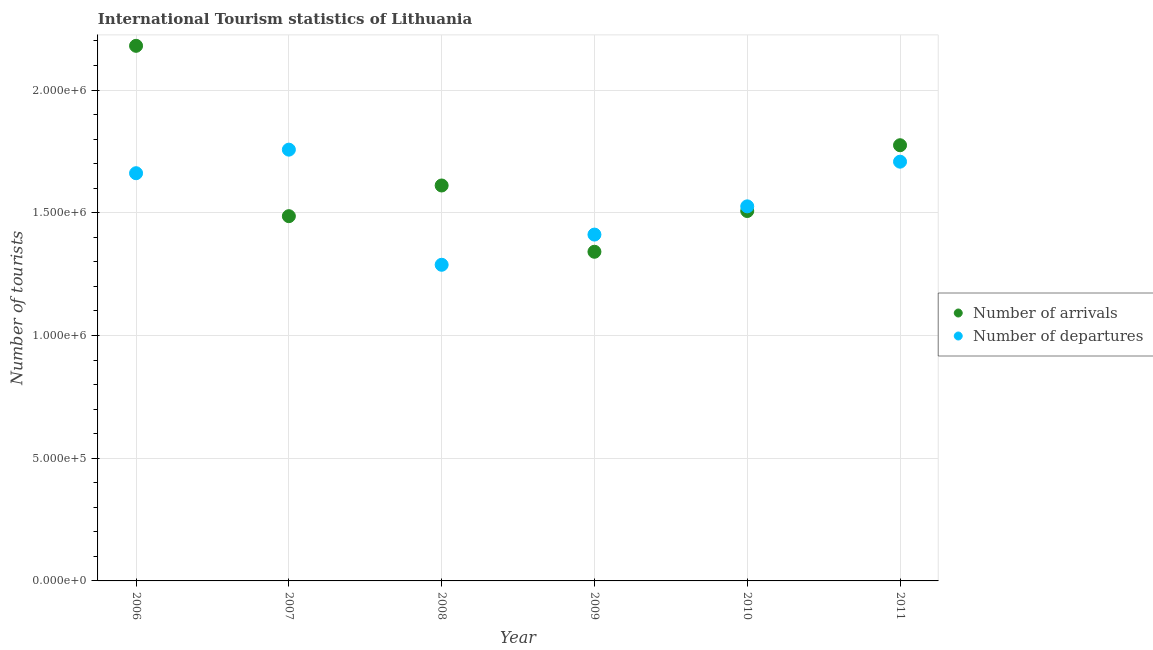How many different coloured dotlines are there?
Give a very brief answer. 2. What is the number of tourist departures in 2011?
Provide a succinct answer. 1.71e+06. Across all years, what is the maximum number of tourist departures?
Your answer should be very brief. 1.76e+06. Across all years, what is the minimum number of tourist departures?
Offer a very short reply. 1.29e+06. In which year was the number of tourist arrivals maximum?
Your response must be concise. 2006. What is the total number of tourist arrivals in the graph?
Provide a succinct answer. 9.90e+06. What is the difference between the number of tourist arrivals in 2008 and that in 2010?
Make the answer very short. 1.04e+05. What is the difference between the number of tourist departures in 2011 and the number of tourist arrivals in 2009?
Make the answer very short. 3.67e+05. What is the average number of tourist departures per year?
Provide a short and direct response. 1.56e+06. In the year 2009, what is the difference between the number of tourist arrivals and number of tourist departures?
Give a very brief answer. -7.00e+04. In how many years, is the number of tourist arrivals greater than 500000?
Make the answer very short. 6. What is the ratio of the number of tourist departures in 2010 to that in 2011?
Keep it short and to the point. 0.89. Is the number of tourist departures in 2008 less than that in 2009?
Give a very brief answer. Yes. Is the difference between the number of tourist departures in 2006 and 2008 greater than the difference between the number of tourist arrivals in 2006 and 2008?
Provide a succinct answer. No. What is the difference between the highest and the second highest number of tourist arrivals?
Offer a very short reply. 4.05e+05. What is the difference between the highest and the lowest number of tourist departures?
Give a very brief answer. 4.69e+05. In how many years, is the number of tourist arrivals greater than the average number of tourist arrivals taken over all years?
Provide a succinct answer. 2. Does the number of tourist arrivals monotonically increase over the years?
Your answer should be very brief. No. Is the number of tourist arrivals strictly less than the number of tourist departures over the years?
Offer a very short reply. No. What is the difference between two consecutive major ticks on the Y-axis?
Make the answer very short. 5.00e+05. Does the graph contain grids?
Your response must be concise. Yes. Where does the legend appear in the graph?
Your answer should be very brief. Center right. How many legend labels are there?
Make the answer very short. 2. What is the title of the graph?
Provide a succinct answer. International Tourism statistics of Lithuania. Does "Death rate" appear as one of the legend labels in the graph?
Give a very brief answer. No. What is the label or title of the Y-axis?
Offer a very short reply. Number of tourists. What is the Number of tourists of Number of arrivals in 2006?
Your answer should be very brief. 2.18e+06. What is the Number of tourists of Number of departures in 2006?
Keep it short and to the point. 1.66e+06. What is the Number of tourists in Number of arrivals in 2007?
Your answer should be compact. 1.49e+06. What is the Number of tourists of Number of departures in 2007?
Give a very brief answer. 1.76e+06. What is the Number of tourists of Number of arrivals in 2008?
Your response must be concise. 1.61e+06. What is the Number of tourists of Number of departures in 2008?
Give a very brief answer. 1.29e+06. What is the Number of tourists of Number of arrivals in 2009?
Give a very brief answer. 1.34e+06. What is the Number of tourists of Number of departures in 2009?
Give a very brief answer. 1.41e+06. What is the Number of tourists of Number of arrivals in 2010?
Provide a succinct answer. 1.51e+06. What is the Number of tourists of Number of departures in 2010?
Make the answer very short. 1.53e+06. What is the Number of tourists in Number of arrivals in 2011?
Your answer should be compact. 1.78e+06. What is the Number of tourists of Number of departures in 2011?
Provide a succinct answer. 1.71e+06. Across all years, what is the maximum Number of tourists of Number of arrivals?
Provide a short and direct response. 2.18e+06. Across all years, what is the maximum Number of tourists of Number of departures?
Offer a terse response. 1.76e+06. Across all years, what is the minimum Number of tourists of Number of arrivals?
Offer a very short reply. 1.34e+06. Across all years, what is the minimum Number of tourists of Number of departures?
Offer a very short reply. 1.29e+06. What is the total Number of tourists in Number of arrivals in the graph?
Make the answer very short. 9.90e+06. What is the total Number of tourists in Number of departures in the graph?
Give a very brief answer. 9.35e+06. What is the difference between the Number of tourists in Number of arrivals in 2006 and that in 2007?
Your response must be concise. 6.94e+05. What is the difference between the Number of tourists in Number of departures in 2006 and that in 2007?
Ensure brevity in your answer.  -9.60e+04. What is the difference between the Number of tourists of Number of arrivals in 2006 and that in 2008?
Make the answer very short. 5.69e+05. What is the difference between the Number of tourists of Number of departures in 2006 and that in 2008?
Your answer should be very brief. 3.73e+05. What is the difference between the Number of tourists of Number of arrivals in 2006 and that in 2009?
Ensure brevity in your answer.  8.39e+05. What is the difference between the Number of tourists of Number of departures in 2006 and that in 2009?
Your response must be concise. 2.50e+05. What is the difference between the Number of tourists in Number of arrivals in 2006 and that in 2010?
Keep it short and to the point. 6.73e+05. What is the difference between the Number of tourists in Number of departures in 2006 and that in 2010?
Offer a very short reply. 1.35e+05. What is the difference between the Number of tourists of Number of arrivals in 2006 and that in 2011?
Offer a terse response. 4.05e+05. What is the difference between the Number of tourists of Number of departures in 2006 and that in 2011?
Offer a very short reply. -4.70e+04. What is the difference between the Number of tourists of Number of arrivals in 2007 and that in 2008?
Your response must be concise. -1.25e+05. What is the difference between the Number of tourists in Number of departures in 2007 and that in 2008?
Provide a succinct answer. 4.69e+05. What is the difference between the Number of tourists in Number of arrivals in 2007 and that in 2009?
Your response must be concise. 1.45e+05. What is the difference between the Number of tourists in Number of departures in 2007 and that in 2009?
Make the answer very short. 3.46e+05. What is the difference between the Number of tourists of Number of arrivals in 2007 and that in 2010?
Provide a short and direct response. -2.10e+04. What is the difference between the Number of tourists of Number of departures in 2007 and that in 2010?
Ensure brevity in your answer.  2.31e+05. What is the difference between the Number of tourists in Number of arrivals in 2007 and that in 2011?
Your answer should be very brief. -2.89e+05. What is the difference between the Number of tourists in Number of departures in 2007 and that in 2011?
Your response must be concise. 4.90e+04. What is the difference between the Number of tourists of Number of departures in 2008 and that in 2009?
Make the answer very short. -1.23e+05. What is the difference between the Number of tourists in Number of arrivals in 2008 and that in 2010?
Keep it short and to the point. 1.04e+05. What is the difference between the Number of tourists in Number of departures in 2008 and that in 2010?
Provide a short and direct response. -2.38e+05. What is the difference between the Number of tourists of Number of arrivals in 2008 and that in 2011?
Make the answer very short. -1.64e+05. What is the difference between the Number of tourists of Number of departures in 2008 and that in 2011?
Provide a short and direct response. -4.20e+05. What is the difference between the Number of tourists in Number of arrivals in 2009 and that in 2010?
Your response must be concise. -1.66e+05. What is the difference between the Number of tourists of Number of departures in 2009 and that in 2010?
Your response must be concise. -1.15e+05. What is the difference between the Number of tourists in Number of arrivals in 2009 and that in 2011?
Your answer should be very brief. -4.34e+05. What is the difference between the Number of tourists of Number of departures in 2009 and that in 2011?
Provide a succinct answer. -2.97e+05. What is the difference between the Number of tourists in Number of arrivals in 2010 and that in 2011?
Provide a short and direct response. -2.68e+05. What is the difference between the Number of tourists of Number of departures in 2010 and that in 2011?
Your answer should be compact. -1.82e+05. What is the difference between the Number of tourists in Number of arrivals in 2006 and the Number of tourists in Number of departures in 2007?
Your response must be concise. 4.23e+05. What is the difference between the Number of tourists in Number of arrivals in 2006 and the Number of tourists in Number of departures in 2008?
Provide a short and direct response. 8.92e+05. What is the difference between the Number of tourists of Number of arrivals in 2006 and the Number of tourists of Number of departures in 2009?
Ensure brevity in your answer.  7.69e+05. What is the difference between the Number of tourists in Number of arrivals in 2006 and the Number of tourists in Number of departures in 2010?
Provide a succinct answer. 6.54e+05. What is the difference between the Number of tourists of Number of arrivals in 2006 and the Number of tourists of Number of departures in 2011?
Your response must be concise. 4.72e+05. What is the difference between the Number of tourists in Number of arrivals in 2007 and the Number of tourists in Number of departures in 2008?
Provide a succinct answer. 1.98e+05. What is the difference between the Number of tourists in Number of arrivals in 2007 and the Number of tourists in Number of departures in 2009?
Offer a terse response. 7.50e+04. What is the difference between the Number of tourists of Number of arrivals in 2007 and the Number of tourists of Number of departures in 2011?
Keep it short and to the point. -2.22e+05. What is the difference between the Number of tourists in Number of arrivals in 2008 and the Number of tourists in Number of departures in 2009?
Provide a short and direct response. 2.00e+05. What is the difference between the Number of tourists of Number of arrivals in 2008 and the Number of tourists of Number of departures in 2010?
Your answer should be compact. 8.50e+04. What is the difference between the Number of tourists of Number of arrivals in 2008 and the Number of tourists of Number of departures in 2011?
Provide a short and direct response. -9.70e+04. What is the difference between the Number of tourists in Number of arrivals in 2009 and the Number of tourists in Number of departures in 2010?
Give a very brief answer. -1.85e+05. What is the difference between the Number of tourists of Number of arrivals in 2009 and the Number of tourists of Number of departures in 2011?
Provide a short and direct response. -3.67e+05. What is the difference between the Number of tourists of Number of arrivals in 2010 and the Number of tourists of Number of departures in 2011?
Offer a terse response. -2.01e+05. What is the average Number of tourists of Number of arrivals per year?
Your response must be concise. 1.65e+06. What is the average Number of tourists in Number of departures per year?
Make the answer very short. 1.56e+06. In the year 2006, what is the difference between the Number of tourists of Number of arrivals and Number of tourists of Number of departures?
Your response must be concise. 5.19e+05. In the year 2007, what is the difference between the Number of tourists in Number of arrivals and Number of tourists in Number of departures?
Ensure brevity in your answer.  -2.71e+05. In the year 2008, what is the difference between the Number of tourists in Number of arrivals and Number of tourists in Number of departures?
Your answer should be very brief. 3.23e+05. In the year 2009, what is the difference between the Number of tourists of Number of arrivals and Number of tourists of Number of departures?
Your response must be concise. -7.00e+04. In the year 2010, what is the difference between the Number of tourists of Number of arrivals and Number of tourists of Number of departures?
Ensure brevity in your answer.  -1.90e+04. In the year 2011, what is the difference between the Number of tourists in Number of arrivals and Number of tourists in Number of departures?
Offer a terse response. 6.70e+04. What is the ratio of the Number of tourists of Number of arrivals in 2006 to that in 2007?
Your answer should be very brief. 1.47. What is the ratio of the Number of tourists of Number of departures in 2006 to that in 2007?
Offer a very short reply. 0.95. What is the ratio of the Number of tourists of Number of arrivals in 2006 to that in 2008?
Offer a terse response. 1.35. What is the ratio of the Number of tourists in Number of departures in 2006 to that in 2008?
Your response must be concise. 1.29. What is the ratio of the Number of tourists in Number of arrivals in 2006 to that in 2009?
Ensure brevity in your answer.  1.63. What is the ratio of the Number of tourists of Number of departures in 2006 to that in 2009?
Offer a terse response. 1.18. What is the ratio of the Number of tourists in Number of arrivals in 2006 to that in 2010?
Make the answer very short. 1.45. What is the ratio of the Number of tourists of Number of departures in 2006 to that in 2010?
Make the answer very short. 1.09. What is the ratio of the Number of tourists of Number of arrivals in 2006 to that in 2011?
Keep it short and to the point. 1.23. What is the ratio of the Number of tourists of Number of departures in 2006 to that in 2011?
Your response must be concise. 0.97. What is the ratio of the Number of tourists in Number of arrivals in 2007 to that in 2008?
Your response must be concise. 0.92. What is the ratio of the Number of tourists of Number of departures in 2007 to that in 2008?
Provide a succinct answer. 1.36. What is the ratio of the Number of tourists of Number of arrivals in 2007 to that in 2009?
Provide a short and direct response. 1.11. What is the ratio of the Number of tourists of Number of departures in 2007 to that in 2009?
Provide a succinct answer. 1.25. What is the ratio of the Number of tourists of Number of arrivals in 2007 to that in 2010?
Keep it short and to the point. 0.99. What is the ratio of the Number of tourists in Number of departures in 2007 to that in 2010?
Give a very brief answer. 1.15. What is the ratio of the Number of tourists of Number of arrivals in 2007 to that in 2011?
Give a very brief answer. 0.84. What is the ratio of the Number of tourists in Number of departures in 2007 to that in 2011?
Make the answer very short. 1.03. What is the ratio of the Number of tourists of Number of arrivals in 2008 to that in 2009?
Keep it short and to the point. 1.2. What is the ratio of the Number of tourists of Number of departures in 2008 to that in 2009?
Your answer should be compact. 0.91. What is the ratio of the Number of tourists of Number of arrivals in 2008 to that in 2010?
Provide a short and direct response. 1.07. What is the ratio of the Number of tourists of Number of departures in 2008 to that in 2010?
Your answer should be compact. 0.84. What is the ratio of the Number of tourists of Number of arrivals in 2008 to that in 2011?
Give a very brief answer. 0.91. What is the ratio of the Number of tourists in Number of departures in 2008 to that in 2011?
Offer a terse response. 0.75. What is the ratio of the Number of tourists of Number of arrivals in 2009 to that in 2010?
Your answer should be compact. 0.89. What is the ratio of the Number of tourists in Number of departures in 2009 to that in 2010?
Provide a short and direct response. 0.92. What is the ratio of the Number of tourists of Number of arrivals in 2009 to that in 2011?
Your answer should be compact. 0.76. What is the ratio of the Number of tourists of Number of departures in 2009 to that in 2011?
Provide a succinct answer. 0.83. What is the ratio of the Number of tourists in Number of arrivals in 2010 to that in 2011?
Provide a short and direct response. 0.85. What is the ratio of the Number of tourists in Number of departures in 2010 to that in 2011?
Your response must be concise. 0.89. What is the difference between the highest and the second highest Number of tourists in Number of arrivals?
Provide a short and direct response. 4.05e+05. What is the difference between the highest and the second highest Number of tourists of Number of departures?
Make the answer very short. 4.90e+04. What is the difference between the highest and the lowest Number of tourists in Number of arrivals?
Keep it short and to the point. 8.39e+05. What is the difference between the highest and the lowest Number of tourists in Number of departures?
Give a very brief answer. 4.69e+05. 